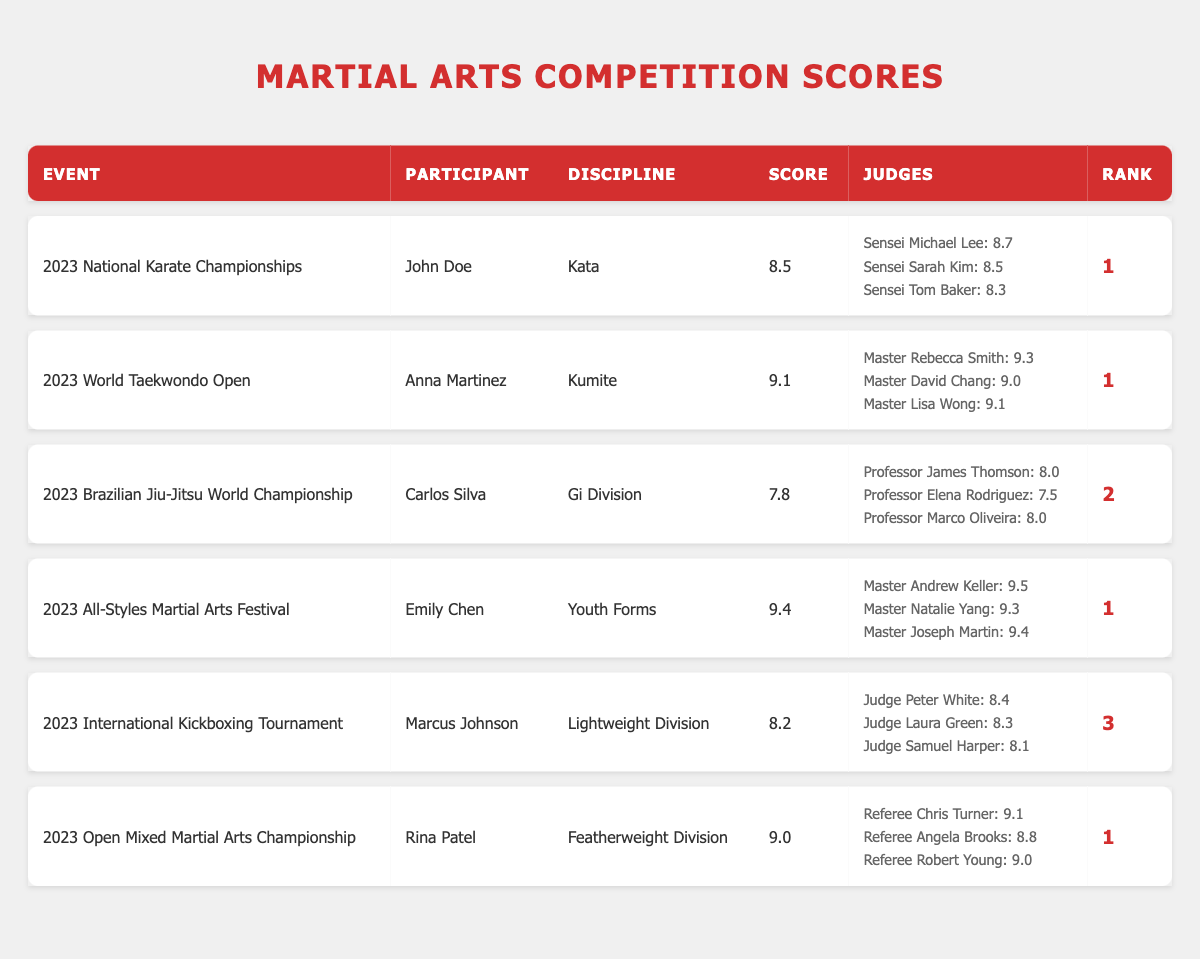What was the highest score achieved in the 2023 Open Mixed Martial Arts Championship? In the 2023 Open Mixed Martial Arts Championship, Rina Patel achieved a score of 9.0, which is the only score listed for this event.
Answer: 9.0 Which participant received the lowest score among all events? Carlos Silva received the lowest score of 7.8 in the 2023 Brazilian Jiu-Jitsu World Championship.
Answer: 7.8 Is it true that all participants in the 2023 World Taekwondo Open received a score of 9.0 or higher? Yes, all judges' scores for Anna Martinez in the 2023 World Taekwondo Open were 9.0 or higher, specifically 9.3, 9.0, and 9.1.
Answer: Yes What is the average score of the judges for Emily Chen in the 2023 All-Styles Martial Arts Festival? The judges' scores for Emily Chen are 9.5, 9.3, and 9.4. Summing them gives 28.2, and dividing by 3 gives an average of 9.4.
Answer: 9.4 How many participants received a rank of 1 in their respective events? A total of 4 participants achieved a rank of 1: John Doe, Anna Martinez, Emily Chen, and Rina Patel. Counting these names gives a total of 4 participants.
Answer: 4 Which discipline had the participant with the highest overall score? Anna Martinez in the Kumite discipline received a score of 9.1, which is the highest score amongst all participants.
Answer: Kumite What was the rank of Marcus Johnson in the 2023 International Kickboxing Tournament? Marcus Johnson's rank in the event was 3, as listed in the table.
Answer: 3 Did any participant score 9.4 in their event? Yes, Emily Chen scored 9.4 in the 2023 All-Styles Martial Arts Festival.
Answer: Yes What was the score difference between the highest and lowest scores in the 2023 Brazilian Jiu-Jitsu World Championship? Carlos Silva scored 7.8, the highest score by Professor James Thomson was 8.0. The difference 8.0 - 7.8 equals 0.2.
Answer: 0.2 